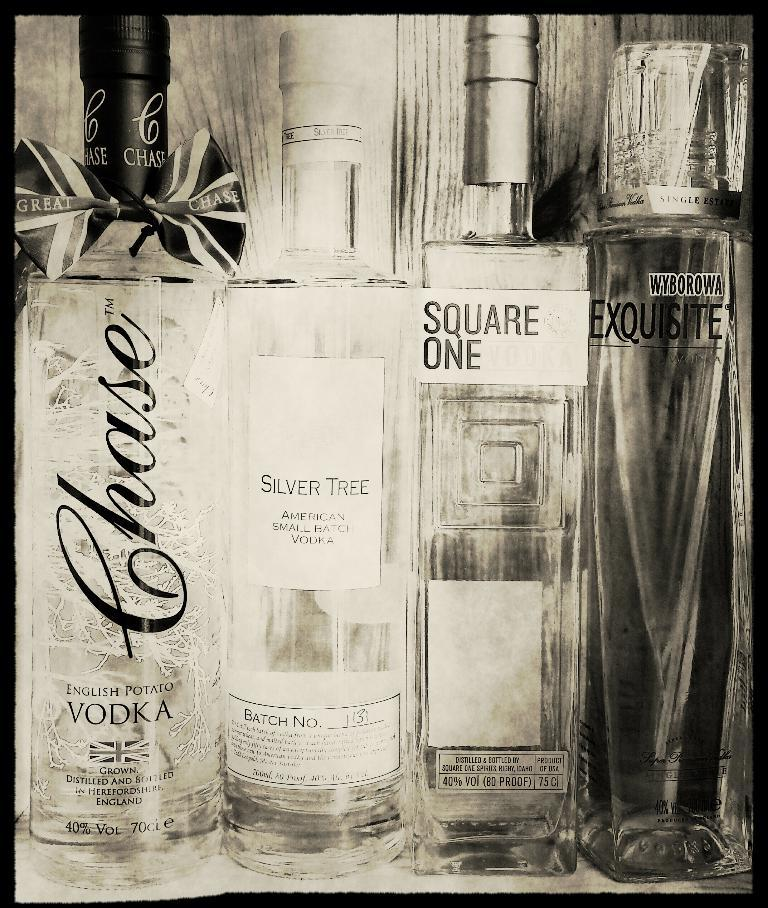<image>
Relay a brief, clear account of the picture shown. A bottle of liquor that describes itself as English Potato Vodka. 